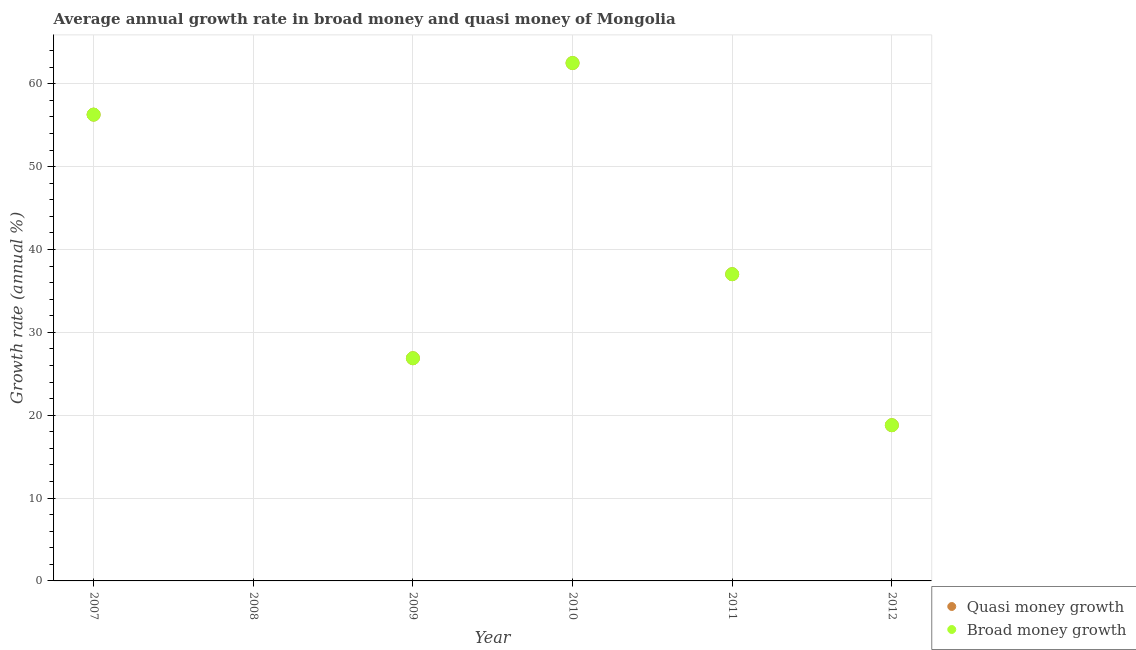What is the annual growth rate in quasi money in 2011?
Provide a succinct answer. 37.01. Across all years, what is the maximum annual growth rate in quasi money?
Ensure brevity in your answer.  62.5. Across all years, what is the minimum annual growth rate in quasi money?
Offer a very short reply. 0. What is the total annual growth rate in broad money in the graph?
Offer a terse response. 201.45. What is the difference between the annual growth rate in quasi money in 2010 and that in 2012?
Offer a terse response. 43.71. What is the difference between the annual growth rate in quasi money in 2007 and the annual growth rate in broad money in 2010?
Offer a terse response. -6.23. What is the average annual growth rate in broad money per year?
Offer a terse response. 33.57. In the year 2011, what is the difference between the annual growth rate in broad money and annual growth rate in quasi money?
Your answer should be very brief. 0. What is the ratio of the annual growth rate in quasi money in 2009 to that in 2011?
Ensure brevity in your answer.  0.73. What is the difference between the highest and the second highest annual growth rate in broad money?
Give a very brief answer. 6.23. What is the difference between the highest and the lowest annual growth rate in broad money?
Offer a terse response. 62.5. Does the annual growth rate in broad money monotonically increase over the years?
Offer a terse response. No. Is the annual growth rate in quasi money strictly less than the annual growth rate in broad money over the years?
Ensure brevity in your answer.  No. What is the difference between two consecutive major ticks on the Y-axis?
Provide a short and direct response. 10. Are the values on the major ticks of Y-axis written in scientific E-notation?
Offer a terse response. No. What is the title of the graph?
Keep it short and to the point. Average annual growth rate in broad money and quasi money of Mongolia. What is the label or title of the X-axis?
Your answer should be compact. Year. What is the label or title of the Y-axis?
Keep it short and to the point. Growth rate (annual %). What is the Growth rate (annual %) of Quasi money growth in 2007?
Provide a succinct answer. 56.27. What is the Growth rate (annual %) in Broad money growth in 2007?
Keep it short and to the point. 56.27. What is the Growth rate (annual %) of Quasi money growth in 2008?
Your answer should be compact. 0. What is the Growth rate (annual %) in Quasi money growth in 2009?
Provide a short and direct response. 26.87. What is the Growth rate (annual %) of Broad money growth in 2009?
Provide a short and direct response. 26.87. What is the Growth rate (annual %) of Quasi money growth in 2010?
Keep it short and to the point. 62.5. What is the Growth rate (annual %) in Broad money growth in 2010?
Keep it short and to the point. 62.5. What is the Growth rate (annual %) in Quasi money growth in 2011?
Ensure brevity in your answer.  37.01. What is the Growth rate (annual %) in Broad money growth in 2011?
Ensure brevity in your answer.  37.01. What is the Growth rate (annual %) in Quasi money growth in 2012?
Your answer should be compact. 18.79. What is the Growth rate (annual %) of Broad money growth in 2012?
Provide a short and direct response. 18.79. Across all years, what is the maximum Growth rate (annual %) in Quasi money growth?
Give a very brief answer. 62.5. Across all years, what is the maximum Growth rate (annual %) of Broad money growth?
Your response must be concise. 62.5. Across all years, what is the minimum Growth rate (annual %) in Broad money growth?
Offer a very short reply. 0. What is the total Growth rate (annual %) in Quasi money growth in the graph?
Give a very brief answer. 201.45. What is the total Growth rate (annual %) of Broad money growth in the graph?
Your response must be concise. 201.45. What is the difference between the Growth rate (annual %) in Quasi money growth in 2007 and that in 2009?
Make the answer very short. 29.4. What is the difference between the Growth rate (annual %) of Broad money growth in 2007 and that in 2009?
Your response must be concise. 29.4. What is the difference between the Growth rate (annual %) in Quasi money growth in 2007 and that in 2010?
Make the answer very short. -6.23. What is the difference between the Growth rate (annual %) in Broad money growth in 2007 and that in 2010?
Provide a succinct answer. -6.23. What is the difference between the Growth rate (annual %) in Quasi money growth in 2007 and that in 2011?
Your response must be concise. 19.26. What is the difference between the Growth rate (annual %) in Broad money growth in 2007 and that in 2011?
Give a very brief answer. 19.26. What is the difference between the Growth rate (annual %) in Quasi money growth in 2007 and that in 2012?
Provide a succinct answer. 37.48. What is the difference between the Growth rate (annual %) in Broad money growth in 2007 and that in 2012?
Make the answer very short. 37.48. What is the difference between the Growth rate (annual %) of Quasi money growth in 2009 and that in 2010?
Provide a short and direct response. -35.62. What is the difference between the Growth rate (annual %) in Broad money growth in 2009 and that in 2010?
Make the answer very short. -35.62. What is the difference between the Growth rate (annual %) in Quasi money growth in 2009 and that in 2011?
Your answer should be compact. -10.14. What is the difference between the Growth rate (annual %) of Broad money growth in 2009 and that in 2011?
Your answer should be very brief. -10.14. What is the difference between the Growth rate (annual %) of Quasi money growth in 2009 and that in 2012?
Your answer should be compact. 8.08. What is the difference between the Growth rate (annual %) in Broad money growth in 2009 and that in 2012?
Your answer should be compact. 8.08. What is the difference between the Growth rate (annual %) in Quasi money growth in 2010 and that in 2011?
Offer a terse response. 25.48. What is the difference between the Growth rate (annual %) of Broad money growth in 2010 and that in 2011?
Provide a succinct answer. 25.48. What is the difference between the Growth rate (annual %) of Quasi money growth in 2010 and that in 2012?
Provide a succinct answer. 43.71. What is the difference between the Growth rate (annual %) in Broad money growth in 2010 and that in 2012?
Keep it short and to the point. 43.71. What is the difference between the Growth rate (annual %) in Quasi money growth in 2011 and that in 2012?
Offer a terse response. 18.22. What is the difference between the Growth rate (annual %) in Broad money growth in 2011 and that in 2012?
Your answer should be compact. 18.22. What is the difference between the Growth rate (annual %) in Quasi money growth in 2007 and the Growth rate (annual %) in Broad money growth in 2009?
Keep it short and to the point. 29.4. What is the difference between the Growth rate (annual %) of Quasi money growth in 2007 and the Growth rate (annual %) of Broad money growth in 2010?
Make the answer very short. -6.23. What is the difference between the Growth rate (annual %) of Quasi money growth in 2007 and the Growth rate (annual %) of Broad money growth in 2011?
Give a very brief answer. 19.26. What is the difference between the Growth rate (annual %) in Quasi money growth in 2007 and the Growth rate (annual %) in Broad money growth in 2012?
Your answer should be very brief. 37.48. What is the difference between the Growth rate (annual %) in Quasi money growth in 2009 and the Growth rate (annual %) in Broad money growth in 2010?
Offer a very short reply. -35.62. What is the difference between the Growth rate (annual %) of Quasi money growth in 2009 and the Growth rate (annual %) of Broad money growth in 2011?
Provide a succinct answer. -10.14. What is the difference between the Growth rate (annual %) of Quasi money growth in 2009 and the Growth rate (annual %) of Broad money growth in 2012?
Your answer should be compact. 8.08. What is the difference between the Growth rate (annual %) of Quasi money growth in 2010 and the Growth rate (annual %) of Broad money growth in 2011?
Your answer should be very brief. 25.48. What is the difference between the Growth rate (annual %) in Quasi money growth in 2010 and the Growth rate (annual %) in Broad money growth in 2012?
Your response must be concise. 43.71. What is the difference between the Growth rate (annual %) of Quasi money growth in 2011 and the Growth rate (annual %) of Broad money growth in 2012?
Ensure brevity in your answer.  18.22. What is the average Growth rate (annual %) of Quasi money growth per year?
Provide a short and direct response. 33.57. What is the average Growth rate (annual %) of Broad money growth per year?
Give a very brief answer. 33.57. In the year 2010, what is the difference between the Growth rate (annual %) of Quasi money growth and Growth rate (annual %) of Broad money growth?
Your answer should be compact. 0. In the year 2011, what is the difference between the Growth rate (annual %) of Quasi money growth and Growth rate (annual %) of Broad money growth?
Your response must be concise. 0. In the year 2012, what is the difference between the Growth rate (annual %) in Quasi money growth and Growth rate (annual %) in Broad money growth?
Make the answer very short. 0. What is the ratio of the Growth rate (annual %) in Quasi money growth in 2007 to that in 2009?
Your answer should be very brief. 2.09. What is the ratio of the Growth rate (annual %) in Broad money growth in 2007 to that in 2009?
Offer a terse response. 2.09. What is the ratio of the Growth rate (annual %) of Quasi money growth in 2007 to that in 2010?
Give a very brief answer. 0.9. What is the ratio of the Growth rate (annual %) of Broad money growth in 2007 to that in 2010?
Offer a very short reply. 0.9. What is the ratio of the Growth rate (annual %) in Quasi money growth in 2007 to that in 2011?
Keep it short and to the point. 1.52. What is the ratio of the Growth rate (annual %) in Broad money growth in 2007 to that in 2011?
Provide a short and direct response. 1.52. What is the ratio of the Growth rate (annual %) of Quasi money growth in 2007 to that in 2012?
Offer a very short reply. 2.99. What is the ratio of the Growth rate (annual %) in Broad money growth in 2007 to that in 2012?
Your answer should be very brief. 2.99. What is the ratio of the Growth rate (annual %) in Quasi money growth in 2009 to that in 2010?
Offer a very short reply. 0.43. What is the ratio of the Growth rate (annual %) of Broad money growth in 2009 to that in 2010?
Make the answer very short. 0.43. What is the ratio of the Growth rate (annual %) of Quasi money growth in 2009 to that in 2011?
Provide a short and direct response. 0.73. What is the ratio of the Growth rate (annual %) of Broad money growth in 2009 to that in 2011?
Provide a short and direct response. 0.73. What is the ratio of the Growth rate (annual %) in Quasi money growth in 2009 to that in 2012?
Make the answer very short. 1.43. What is the ratio of the Growth rate (annual %) in Broad money growth in 2009 to that in 2012?
Your answer should be compact. 1.43. What is the ratio of the Growth rate (annual %) of Quasi money growth in 2010 to that in 2011?
Ensure brevity in your answer.  1.69. What is the ratio of the Growth rate (annual %) in Broad money growth in 2010 to that in 2011?
Your answer should be compact. 1.69. What is the ratio of the Growth rate (annual %) in Quasi money growth in 2010 to that in 2012?
Ensure brevity in your answer.  3.33. What is the ratio of the Growth rate (annual %) in Broad money growth in 2010 to that in 2012?
Ensure brevity in your answer.  3.33. What is the ratio of the Growth rate (annual %) in Quasi money growth in 2011 to that in 2012?
Provide a succinct answer. 1.97. What is the ratio of the Growth rate (annual %) in Broad money growth in 2011 to that in 2012?
Offer a very short reply. 1.97. What is the difference between the highest and the second highest Growth rate (annual %) of Quasi money growth?
Ensure brevity in your answer.  6.23. What is the difference between the highest and the second highest Growth rate (annual %) in Broad money growth?
Your response must be concise. 6.23. What is the difference between the highest and the lowest Growth rate (annual %) in Quasi money growth?
Ensure brevity in your answer.  62.5. What is the difference between the highest and the lowest Growth rate (annual %) of Broad money growth?
Offer a very short reply. 62.5. 